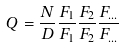<formula> <loc_0><loc_0><loc_500><loc_500>Q = \frac { N } { D } \frac { F _ { 1 } } { F _ { 1 } } \frac { F _ { 2 } } { F _ { 2 } } \frac { F _ { \dots } } { F _ { \dots } }</formula> 